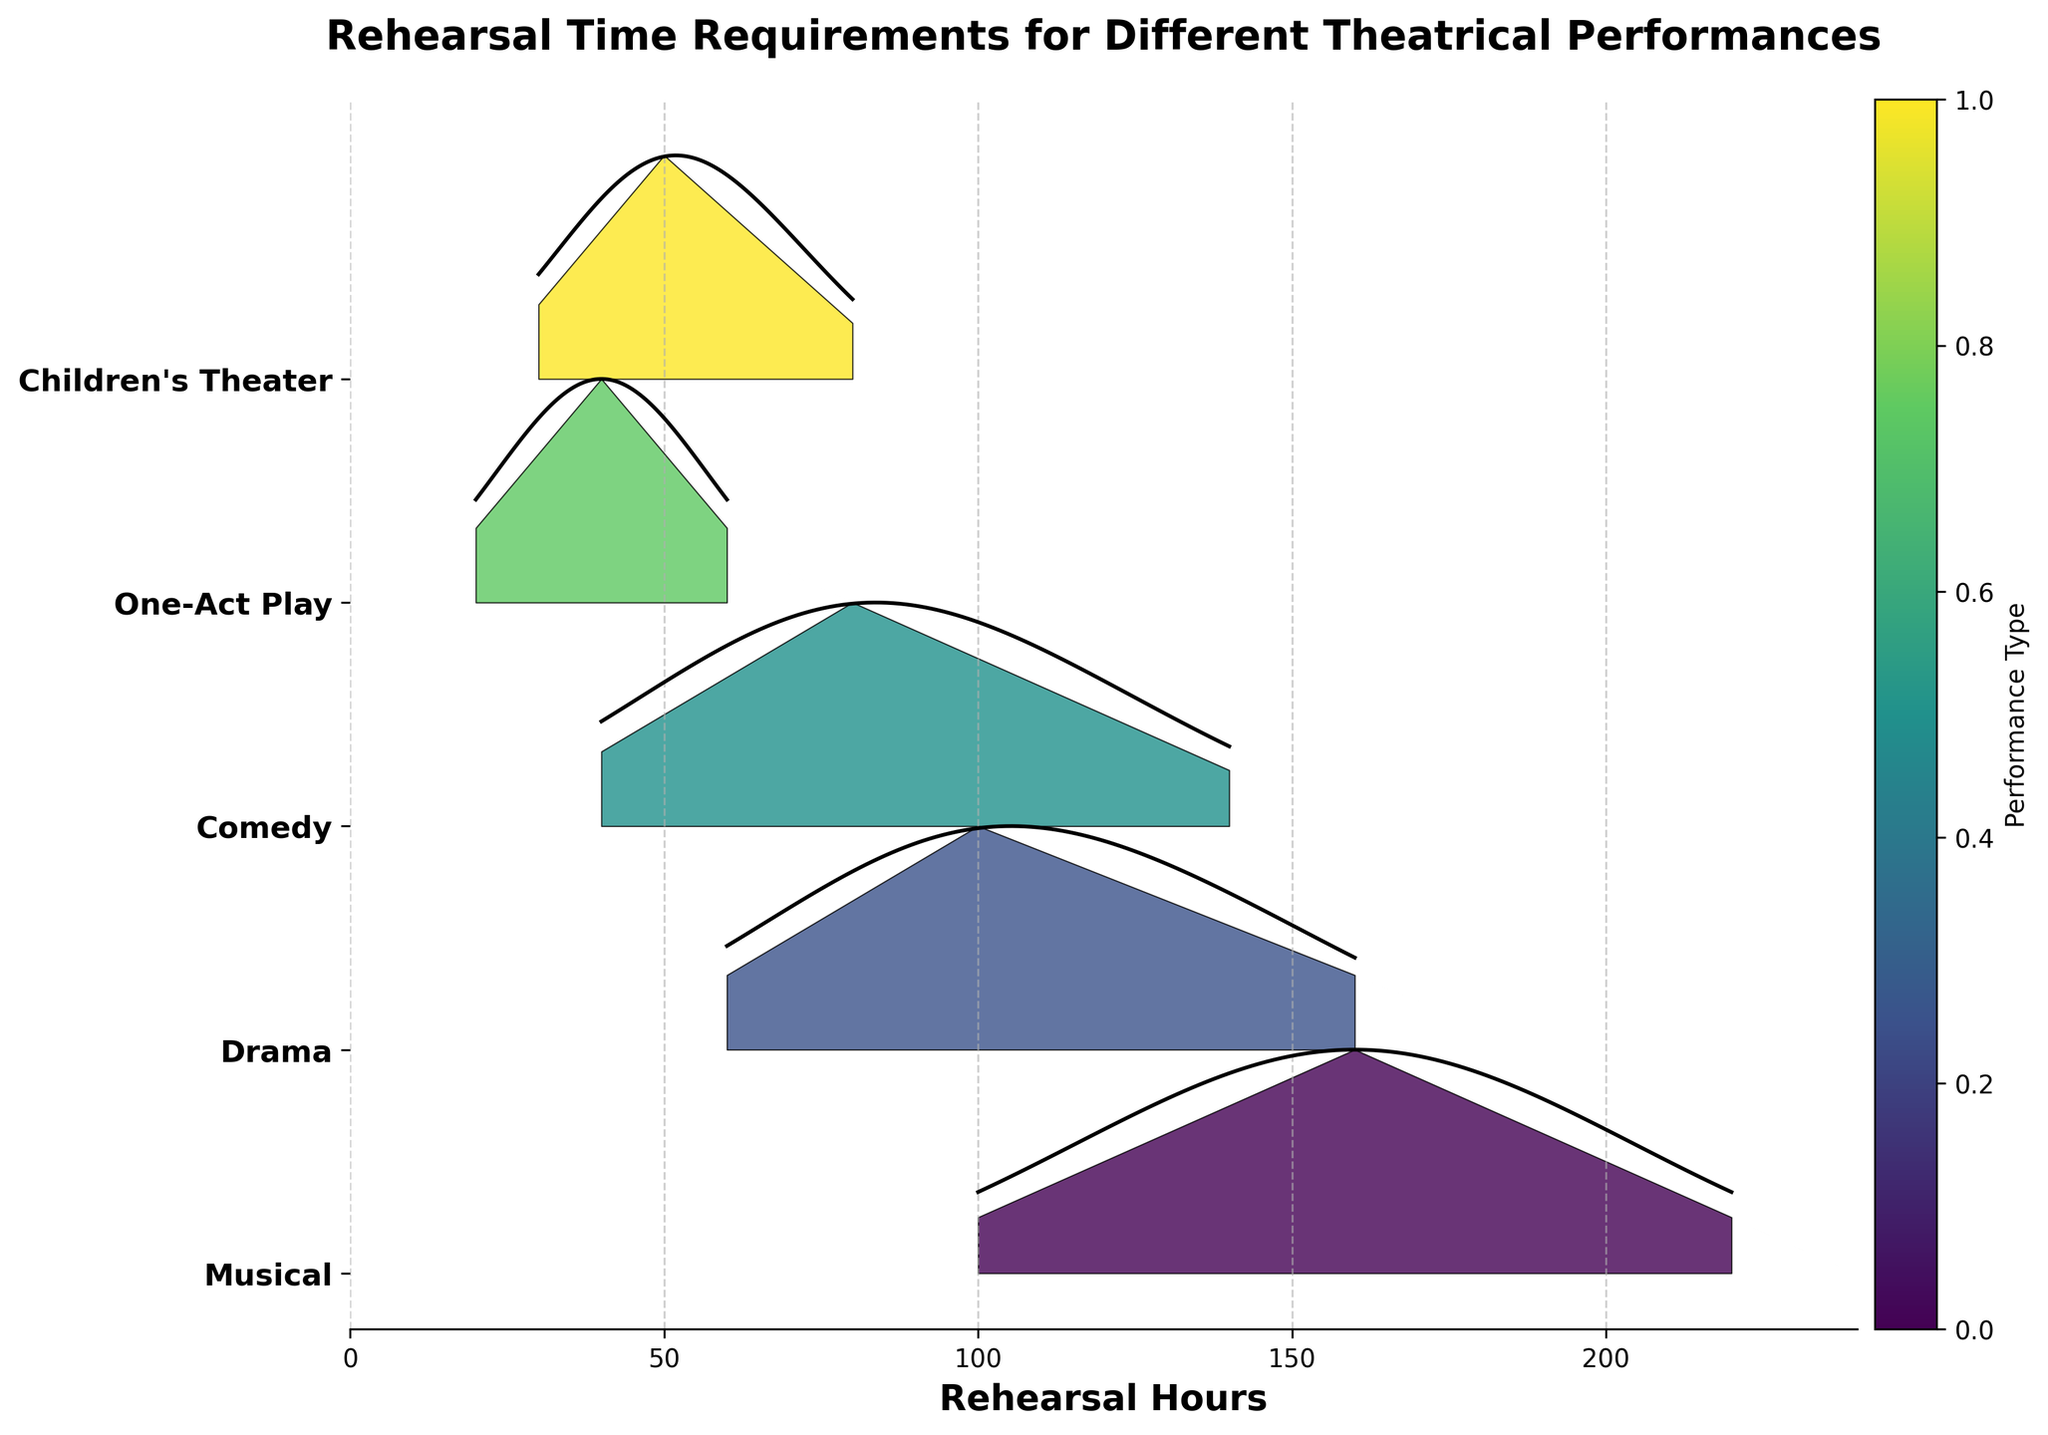How many different performance types are displayed in the plot? The plot contains distinct ridgelines for each performance type. By counting the unique labels on the y-axis, we determine the number of performance types.
Answer: 5 Which performance type requires the highest maximum hours of rehearsal time? By examining the x-axis range for each performance type, the type with the highest maximum is the one with the furthest right data points. Musical extends to 220 hours.
Answer: Musical How does the density distribution of rehearsal hours for Children's Theater compare to Comedy? Observing the peak heights (density values) and their positions along the x-axis for Children's Theater and Comedy allows a comparison. Children's Theater has higher density at lower hours compared to Comedy.
Answer: Children's Theater has higher density at lower hours Which performance type has the widest spread in rehearsal hours? The spread can be gauged by examining the range of hours on the x-axis for each performance type. The widest spread is indicated by the most extensive range. Musical spans from 100 to 220 hours.
Answer: Musical Is the mode of rehearsal hours higher for Drama or Children's Theater? The mode appears at the highest peak of the ridgeline, visible as the highest density point. For Drama, the peak is at 100 hours, while for Children's Theater, the peak is around 50 hours.
Answer: Drama What is the range of rehearsal hours for One-Act Play? The range is determined by identifying the minimum and maximum rehearsal hours represented on the x-axis for One-Act Play. It spans from 20 to 60 hours.
Answer: 20 to 60 hours Between Drama and Comedy, which has a sharper decline in density after hitting its peak? A sharp decline can be identified by looking at the rate of decline in the ridgeline after the peak density point. Drama shows a faster decline after its peak at 100 hours compared to Comedy.
Answer: Drama At what rehearsal hour does Children's Theater density start to significantly decline? By observing the decrease in the y-values of Children's Theater's ridgeline, the significant decline starts to appear after the peak. This is around 50 hours.
Answer: 50 hours Comparing all performance types, which has the lowest minimum rehearsal hours? The lowest minimum is the point furthest left on the x-axis for any performance type. One-Act Play has the lowest starting point at 20 hours.
Answer: One-Act Play 